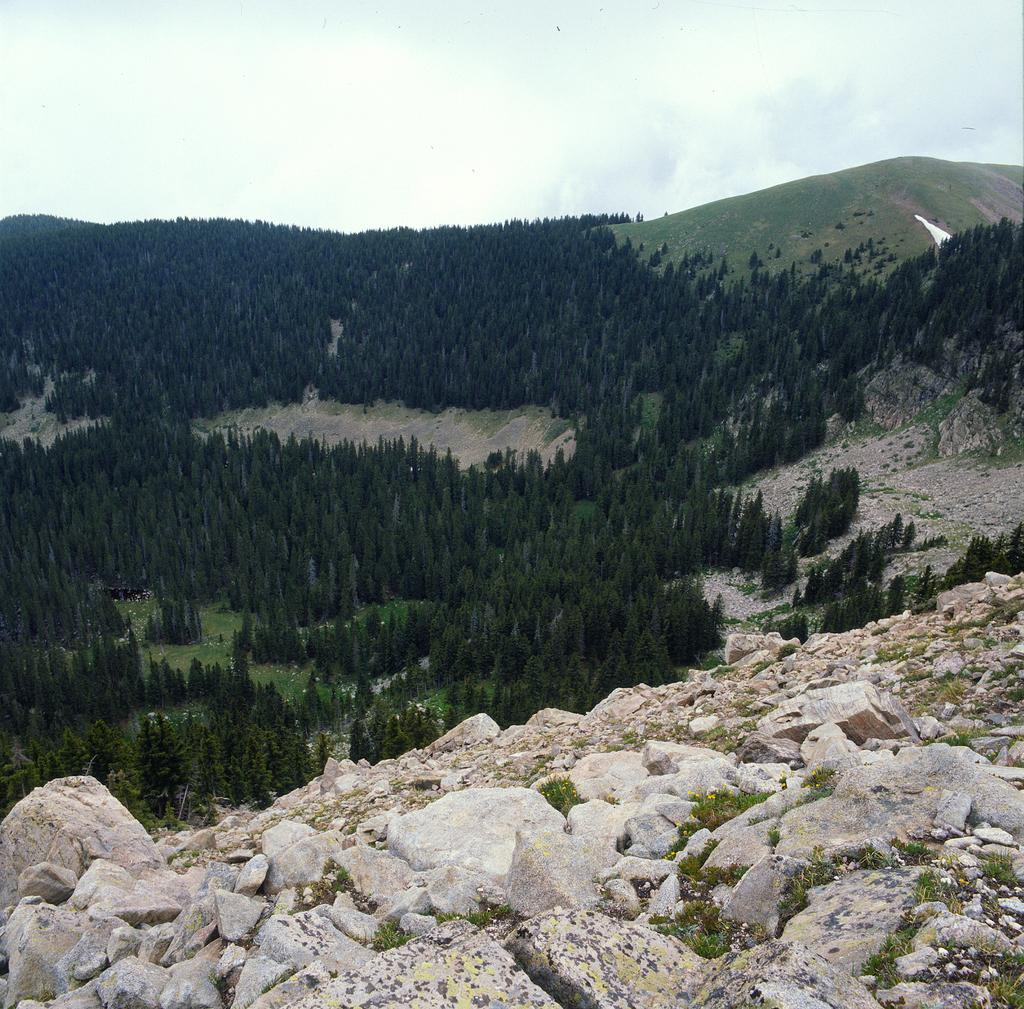What type of natural elements can be seen in the image? There are stones, rocks, trees, grass, and a cloudy sky visible in the image. Can you describe the landscape in the image? The landscape features a group of trees on a hill, surrounded by stones, rocks, and grass. What is the condition of the sky in the image? The sky appears cloudy in the image. How many apples are hanging from the trees in the image? There are no apples visible in the image; the trees are not fruit-bearing trees. What type of knowledge is being shared among the trees in the image? There is no indication of knowledge being shared among the trees in the image, as trees do not possess the ability to share knowledge. 